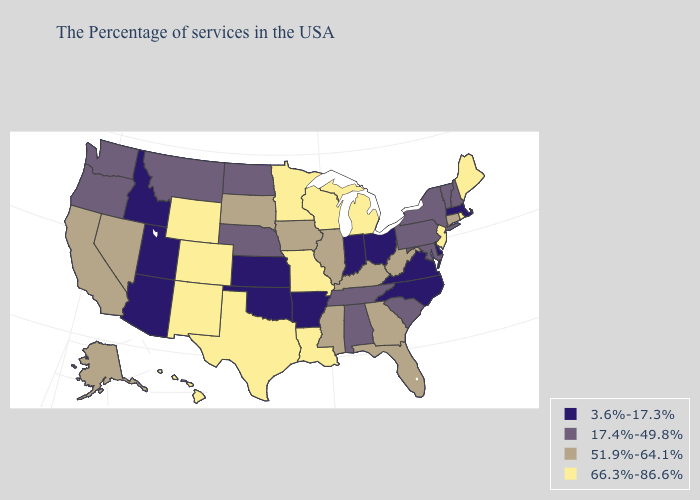Does the first symbol in the legend represent the smallest category?
Give a very brief answer. Yes. What is the value of Alabama?
Concise answer only. 17.4%-49.8%. What is the value of Montana?
Give a very brief answer. 17.4%-49.8%. What is the highest value in states that border Texas?
Short answer required. 66.3%-86.6%. Among the states that border Tennessee , which have the highest value?
Keep it brief. Missouri. Does Louisiana have the highest value in the USA?
Concise answer only. Yes. What is the value of Indiana?
Write a very short answer. 3.6%-17.3%. Which states hav the highest value in the South?
Short answer required. Louisiana, Texas. What is the lowest value in the Northeast?
Be succinct. 3.6%-17.3%. Name the states that have a value in the range 51.9%-64.1%?
Give a very brief answer. Connecticut, West Virginia, Florida, Georgia, Kentucky, Illinois, Mississippi, Iowa, South Dakota, Nevada, California, Alaska. Name the states that have a value in the range 17.4%-49.8%?
Be succinct. New Hampshire, Vermont, New York, Maryland, Pennsylvania, South Carolina, Alabama, Tennessee, Nebraska, North Dakota, Montana, Washington, Oregon. What is the highest value in the Northeast ?
Quick response, please. 66.3%-86.6%. What is the value of Indiana?
Concise answer only. 3.6%-17.3%. Among the states that border Michigan , does Ohio have the lowest value?
Quick response, please. Yes. Which states hav the highest value in the Northeast?
Give a very brief answer. Maine, Rhode Island, New Jersey. 